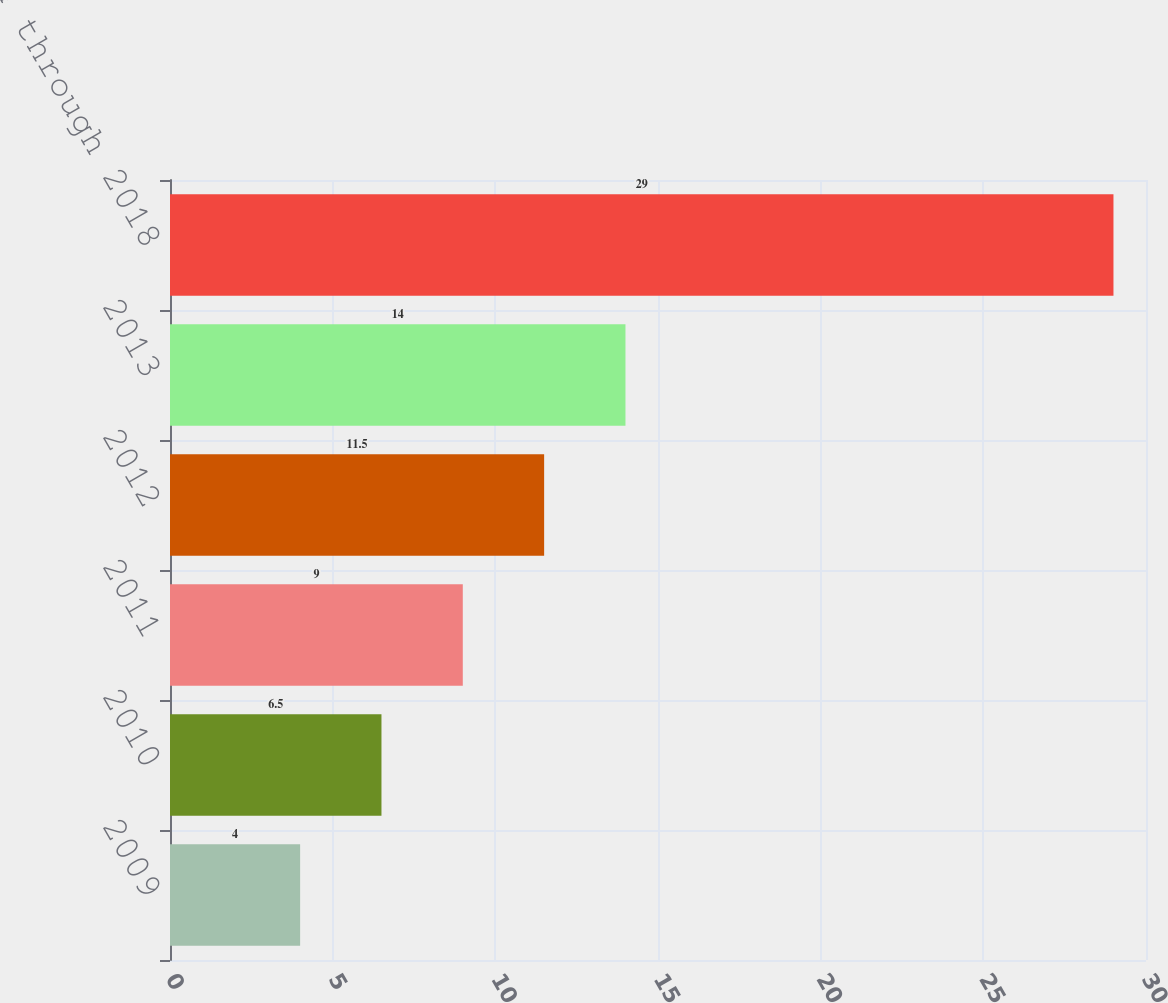Convert chart. <chart><loc_0><loc_0><loc_500><loc_500><bar_chart><fcel>2009<fcel>2010<fcel>2011<fcel>2012<fcel>2013<fcel>2014 through 2018<nl><fcel>4<fcel>6.5<fcel>9<fcel>11.5<fcel>14<fcel>29<nl></chart> 